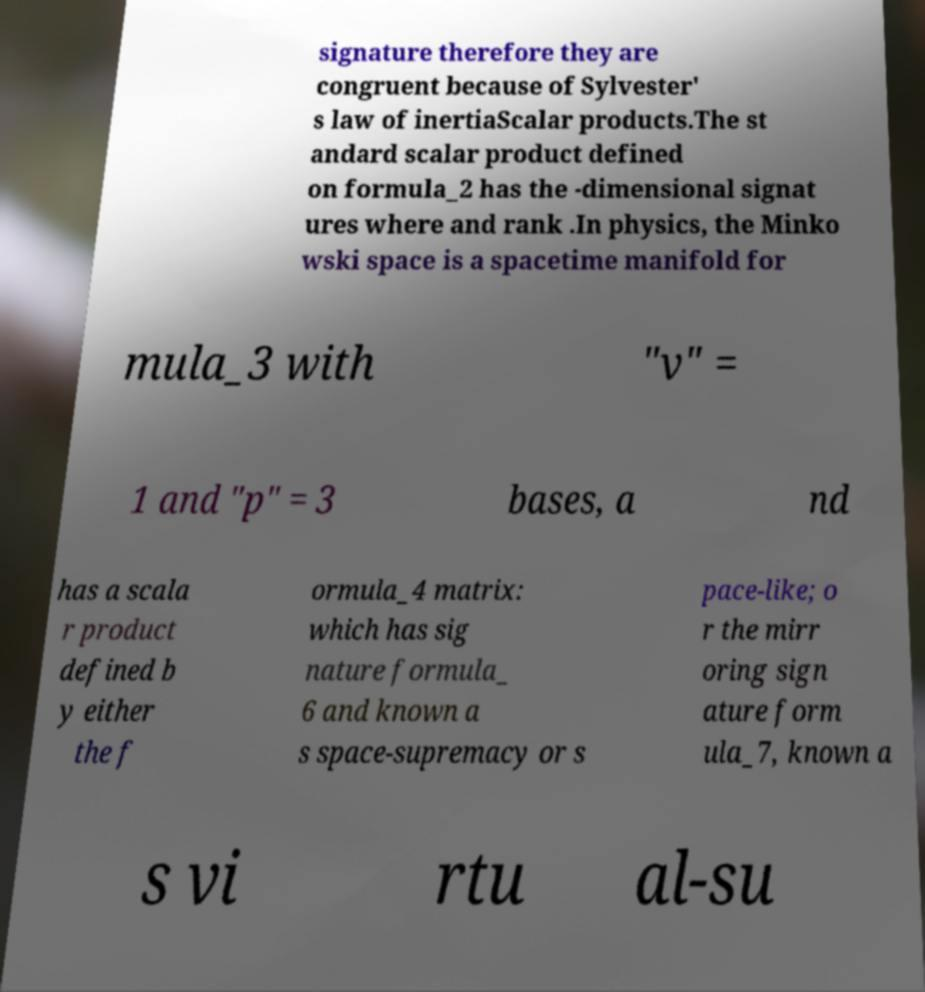Can you read and provide the text displayed in the image?This photo seems to have some interesting text. Can you extract and type it out for me? signature therefore they are congruent because of Sylvester' s law of inertiaScalar products.The st andard scalar product defined on formula_2 has the -dimensional signat ures where and rank .In physics, the Minko wski space is a spacetime manifold for mula_3 with "v" = 1 and "p" = 3 bases, a nd has a scala r product defined b y either the f ormula_4 matrix: which has sig nature formula_ 6 and known a s space-supremacy or s pace-like; o r the mirr oring sign ature form ula_7, known a s vi rtu al-su 